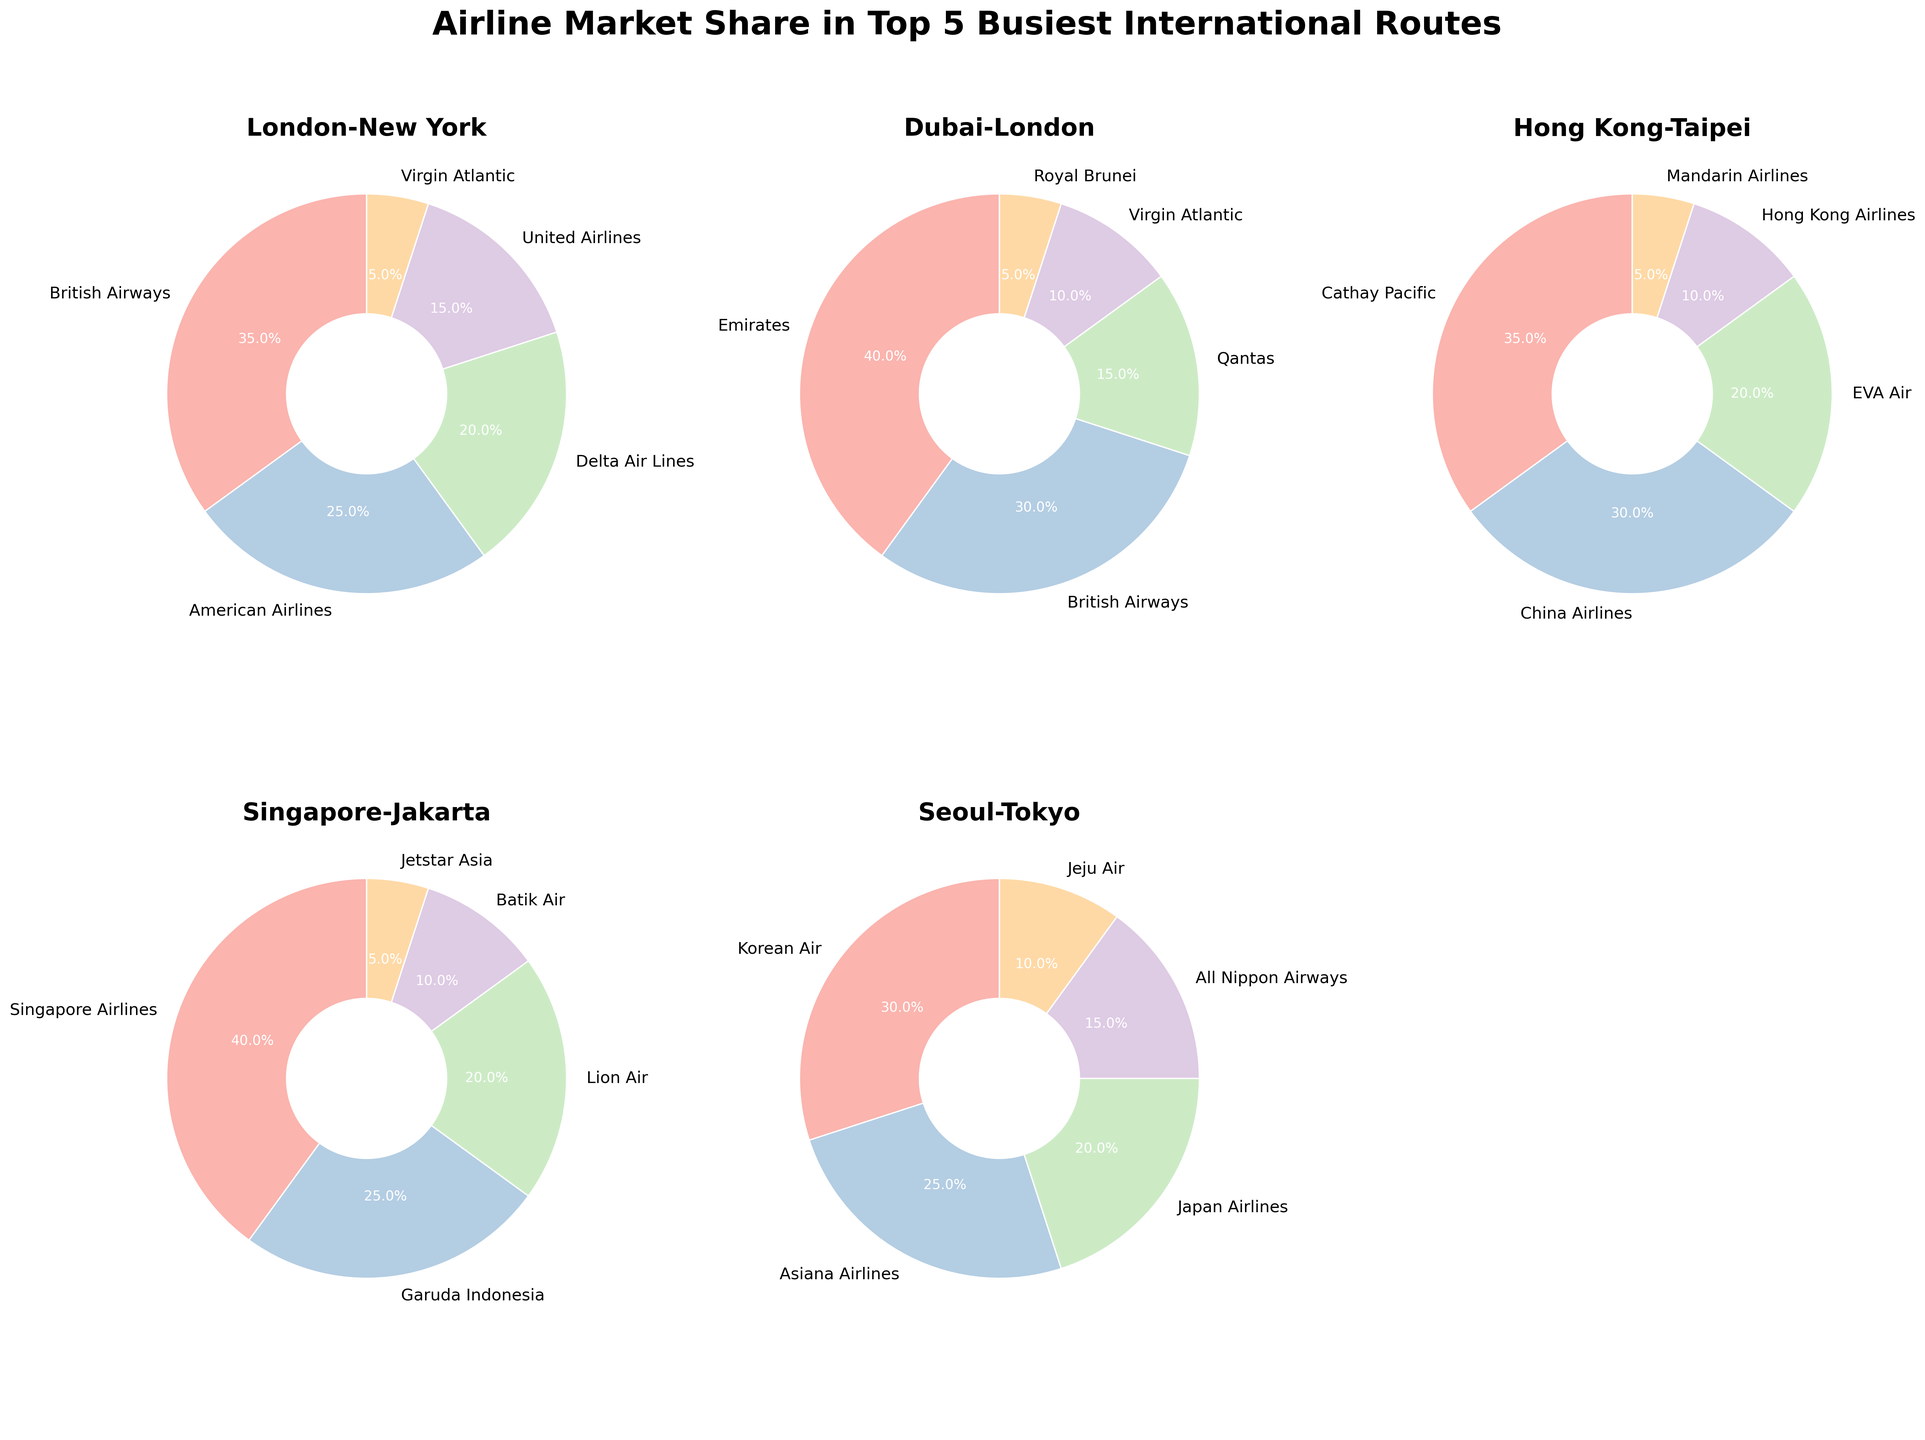What's the market share of British Airways on the London-New York route? To find the market share of British Airways on the London-New York route, refer to the corresponding pie chart segment labeled "British Airways" and note the percentage value.
Answer: 35% Which airline has the smallest market share on the Dubai-London route? Look at the Dubai-London pie chart and identify the segment with the smallest percentage. The label on this segment will indicate the airline with the smallest market share.
Answer: Royal Brunei By how much does Emirates' market share on the Dubai-London route exceed that of Qantas? First, observe the Dubai-London pie chart to find the market shares of Emirates and Qantas. Emirates has 40% and Qantas has 15%. Subtract 15 from 40 to get the difference. 40 - 15 = 25
Answer: 25% Compare the combined market share of Virgin Atlantic across both the London-New York and Dubai-London routes. What's the total? Find Virgin Atlantic's market share on both the London-New York and Dubai-London routes (5% and 10% respectively). Add these percentages together: 5 + 10 = 15
Answer: 15% Which route has the highest market share for a single airline, and what is this market share? Examine each pie chart to find the highest single market share percentage for any airline. Singapore Airlines on the Singapore-Jakarta route has the highest at 40%.
Answer: Singapore-Jakarta, 40% On the Seoul-Tokyo route, how do the market shares of Korean Air and Asiana Airlines compare? Look at the Seoul-Tokyo pie chart to find the market shares of Korean Air and Asiana Airlines. Korean Air has 30% and Asiana Airlines has 25%. Korean Air has a larger share.
Answer: Korean Air has a larger share What's the average market share of the top three airlines on the Hong Kong-Taipei route? Find the market shares for the top three airlines on the Hong Kong-Taipei route: Cathay Pacific (35%), China Airlines (30%), and EVA Air (20%). Calculate the average: (35 + 30 + 20) / 3 = 28.33
Answer: 28.33% What is the combined market share of all airlines except British Airways on the London-New York route? Find the market shares of all other airlines on the London-New York route: American Airlines (25%), Delta Air Lines (20%), United Airlines (15%), and Virgin Atlantic (5%). Sum these values: 25 + 20 + 15 + 5 = 65
Answer: 65% What percentage of the market share on the Singapore-Jakarta route is held by airlines other than Singapore Airlines and Garuda Indonesia? Look at the Singapore-Jakarta pie chart and find the market shares of Lion Air (20%), Batik Air (10%), and Jetstar Asia (5%). Sum these values: 20 + 10 + 5 = 35
Answer: 35% How much larger is the market share of Emirates compared to British Airways on the Dubai-London route? Find the market shares of Emirates and British Airways on the Dubai-London route (40% and 30%). Subtract British Airways' share from Emirates': 40 - 30 = 10
Answer: 10% 